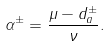Convert formula to latex. <formula><loc_0><loc_0><loc_500><loc_500>\alpha ^ { \pm } = \frac { \mu - d _ { a } ^ { \pm } } { \nu } .</formula> 